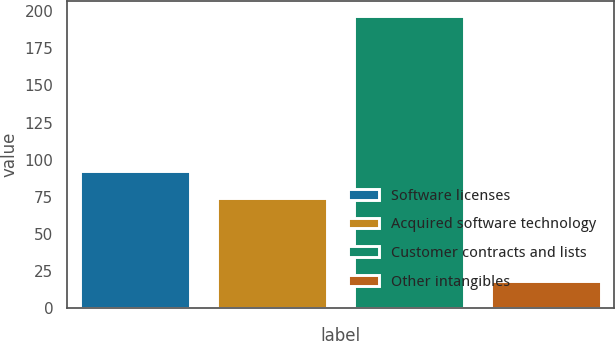Convert chart. <chart><loc_0><loc_0><loc_500><loc_500><bar_chart><fcel>Software licenses<fcel>Acquired software technology<fcel>Customer contracts and lists<fcel>Other intangibles<nl><fcel>92.23<fcel>74.4<fcel>196.8<fcel>18.5<nl></chart> 